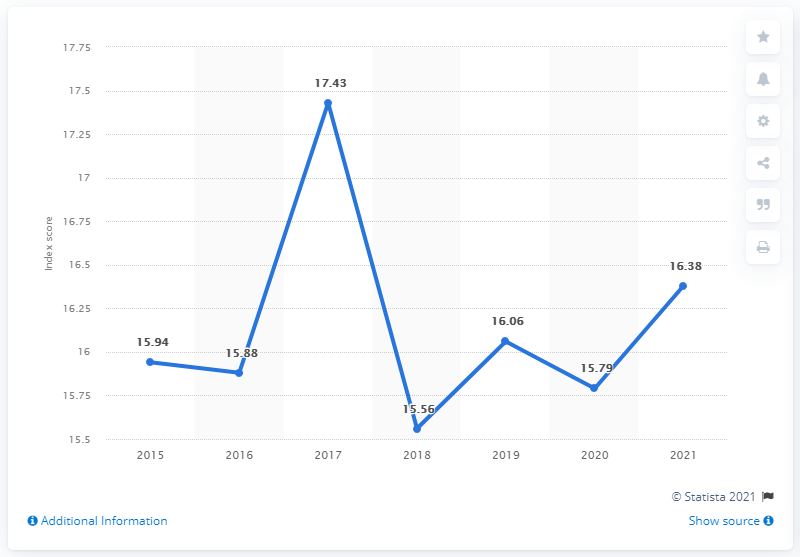List a handful of essential elements in this visual. The sum of indexes except 2017 is 95.61. Uruguay's press freedom index in 2021 was 15.79, indicating a moderate level of press freedom in the country. Approximately how many years have an index greater than 17 from the year 1 up until the present day? 